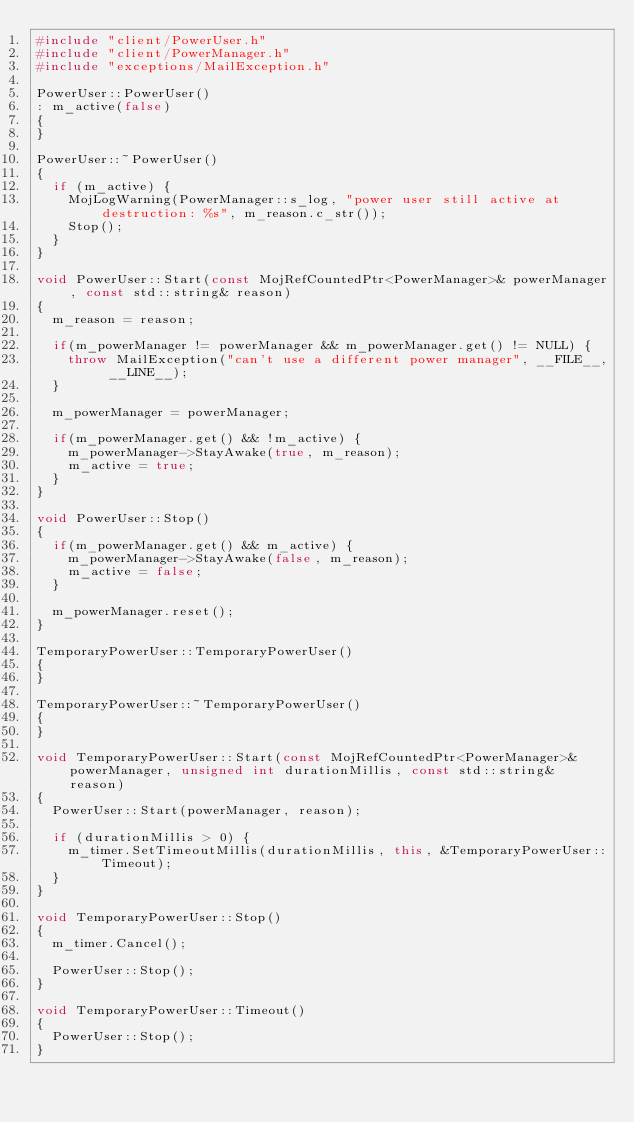<code> <loc_0><loc_0><loc_500><loc_500><_C++_>#include "client/PowerUser.h"
#include "client/PowerManager.h"
#include "exceptions/MailException.h"

PowerUser::PowerUser()
: m_active(false)
{
}

PowerUser::~PowerUser()
{
	if (m_active) {
		MojLogWarning(PowerManager::s_log, "power user still active at destruction: %s", m_reason.c_str());
		Stop();
	}
}

void PowerUser::Start(const MojRefCountedPtr<PowerManager>& powerManager, const std::string& reason)
{
	m_reason = reason;

	if(m_powerManager != powerManager && m_powerManager.get() != NULL) {
		throw MailException("can't use a different power manager", __FILE__, __LINE__);
	}

	m_powerManager = powerManager;

	if(m_powerManager.get() && !m_active) {
		m_powerManager->StayAwake(true, m_reason);
		m_active = true;
	}
}

void PowerUser::Stop()
{
	if(m_powerManager.get() && m_active) {
		m_powerManager->StayAwake(false, m_reason);
		m_active = false;
	}

	m_powerManager.reset();
}

TemporaryPowerUser::TemporaryPowerUser()
{
}

TemporaryPowerUser::~TemporaryPowerUser()
{
}

void TemporaryPowerUser::Start(const MojRefCountedPtr<PowerManager>& powerManager, unsigned int durationMillis, const std::string& reason)
{
	PowerUser::Start(powerManager, reason);

	if (durationMillis > 0) {
		m_timer.SetTimeoutMillis(durationMillis, this, &TemporaryPowerUser::Timeout);
	}
}

void TemporaryPowerUser::Stop()
{
	m_timer.Cancel();

	PowerUser::Stop();
}

void TemporaryPowerUser::Timeout()
{
	PowerUser::Stop();
}
</code> 